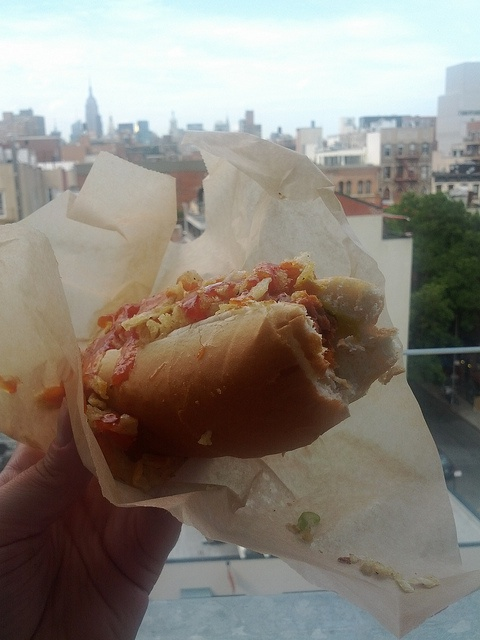Describe the objects in this image and their specific colors. I can see hot dog in lightblue, black, maroon, and gray tones and people in lightblue, black, maroon, and brown tones in this image. 